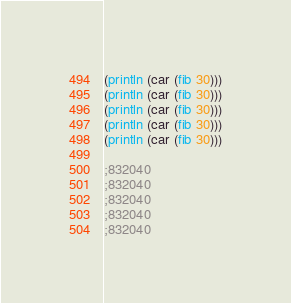<code> <loc_0><loc_0><loc_500><loc_500><_Scheme_>
(println (car (fib 30)))
(println (car (fib 30)))
(println (car (fib 30)))
(println (car (fib 30)))
(println (car (fib 30)))

;832040
;832040
;832040
;832040
;832040
</code> 